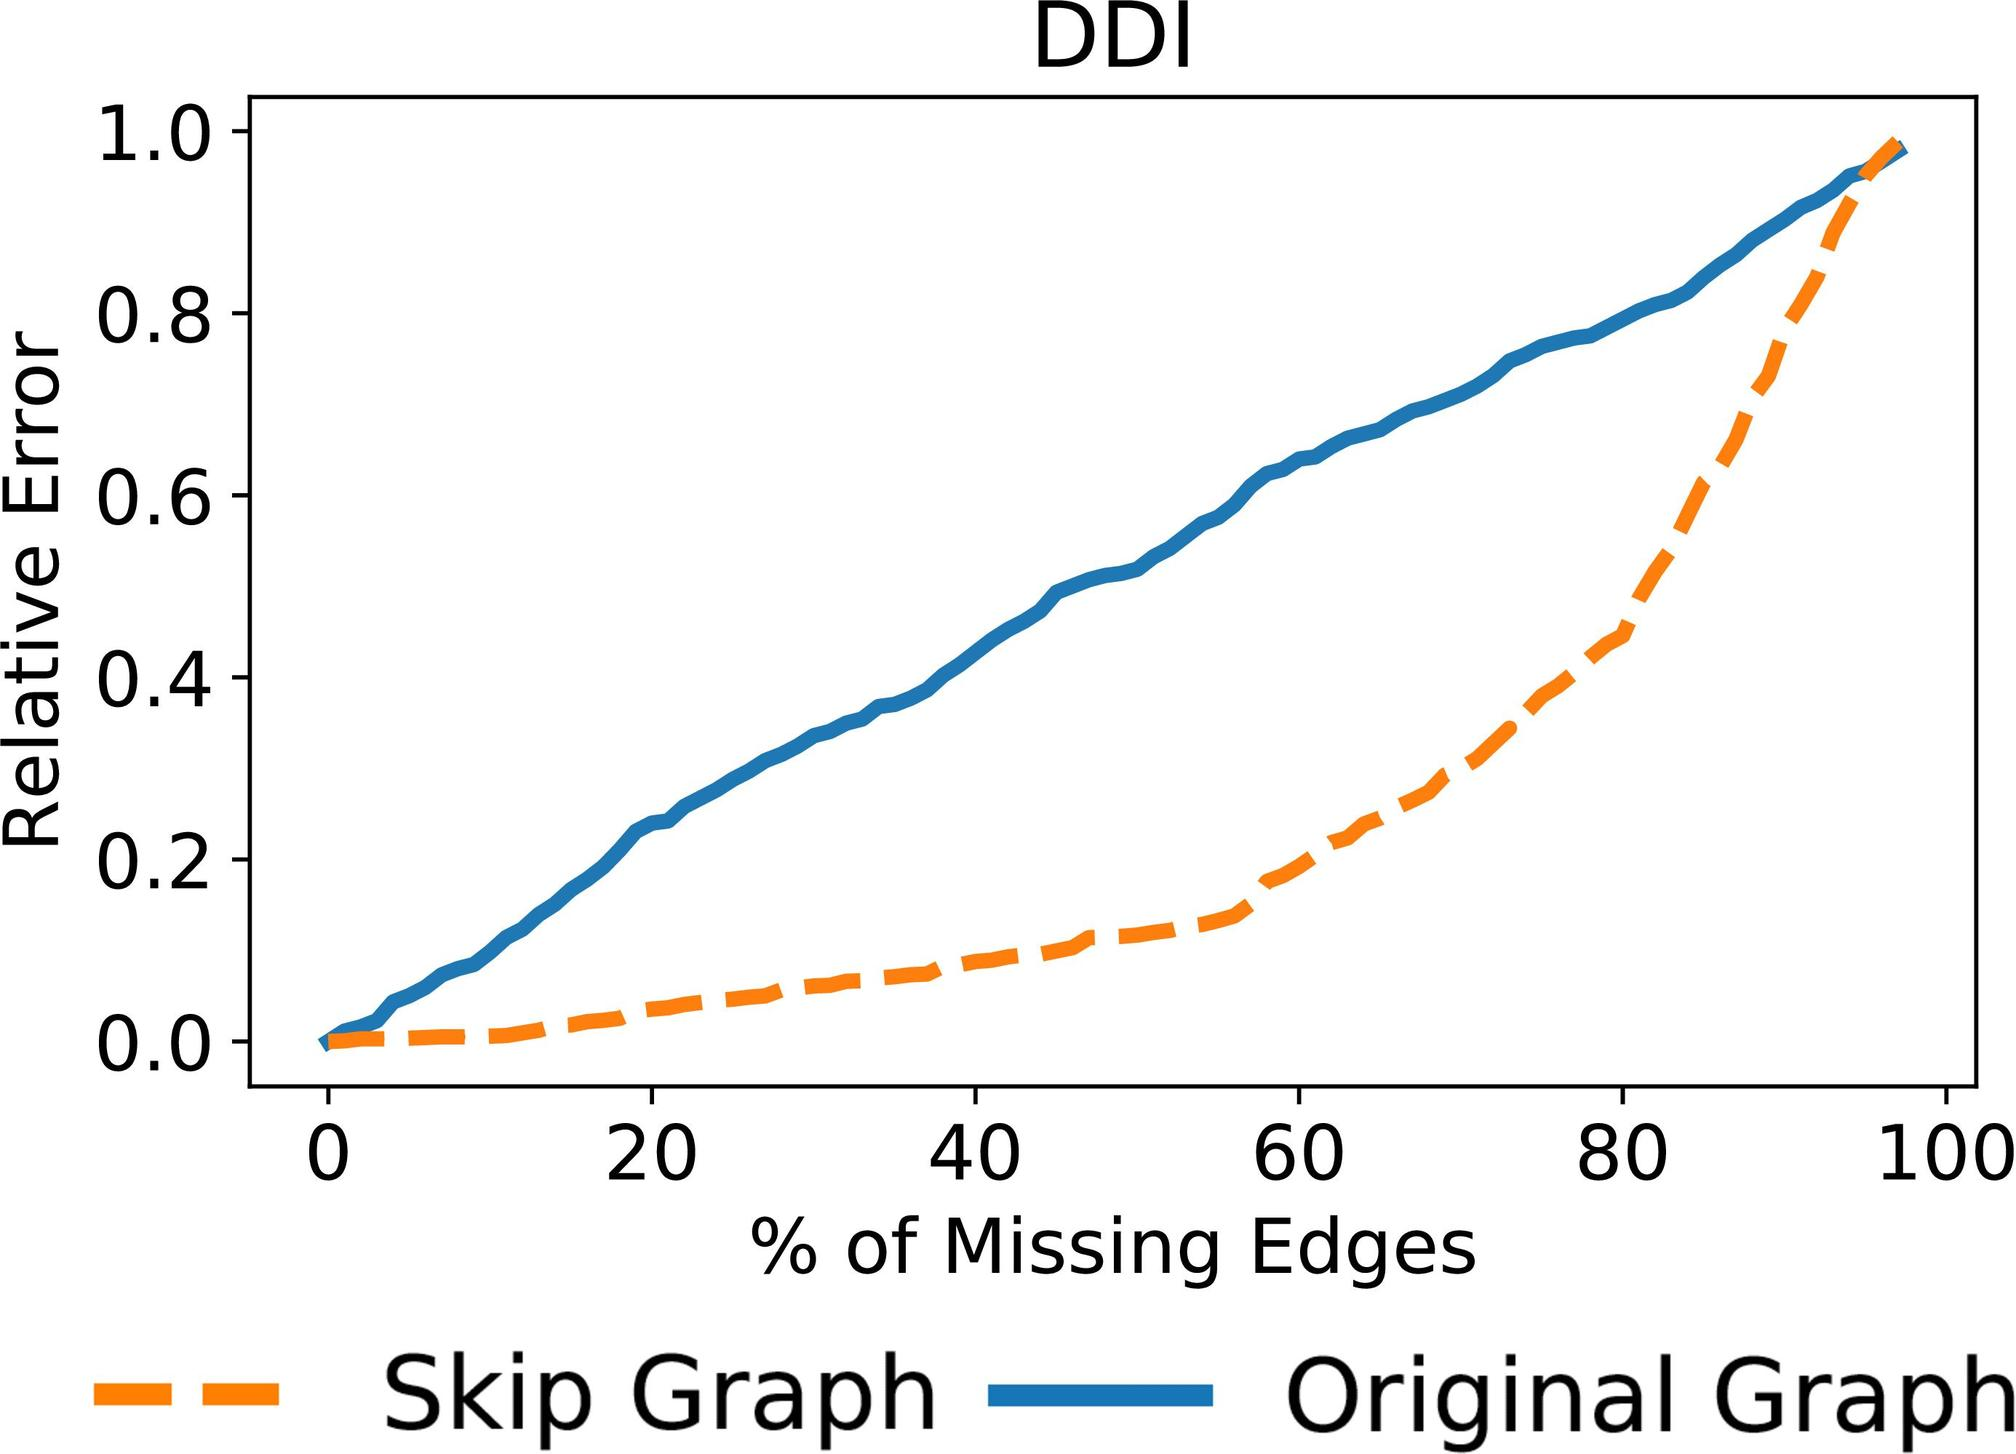What does the solid blue line represent in the graph, and how does its trend compare to the Skip Graph? The solid blue line in the graph represents the 'Original Graph.' Unlike the Skip Graph, its relative error also increases as the percentage of missing edges increases, but at a more pronounced rate. This suggests that the Original Graph is more sensitive to edge loss compared to the Skip Graph, possibly due to differences in structural resilience or error tolerance mechanisms. 